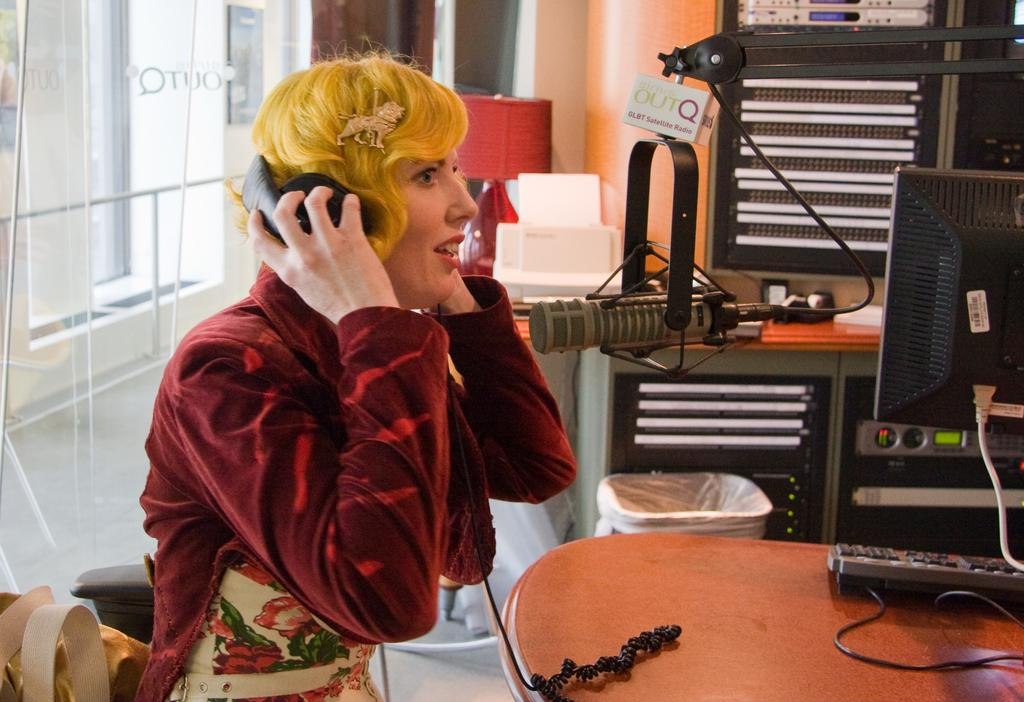Who is the main subject in the image? There is a girl in the image. What is the girl doing in the image? The girl is sitting and singing. What object is present in the image that might be related to the girl's activity? There is a microphone in the image. How many hens can be seen in the image? There are no hens present in the image. What scientific principle is being demonstrated in the image? The image does not depict a scientific principle; it shows a girl singing with a microphone. 